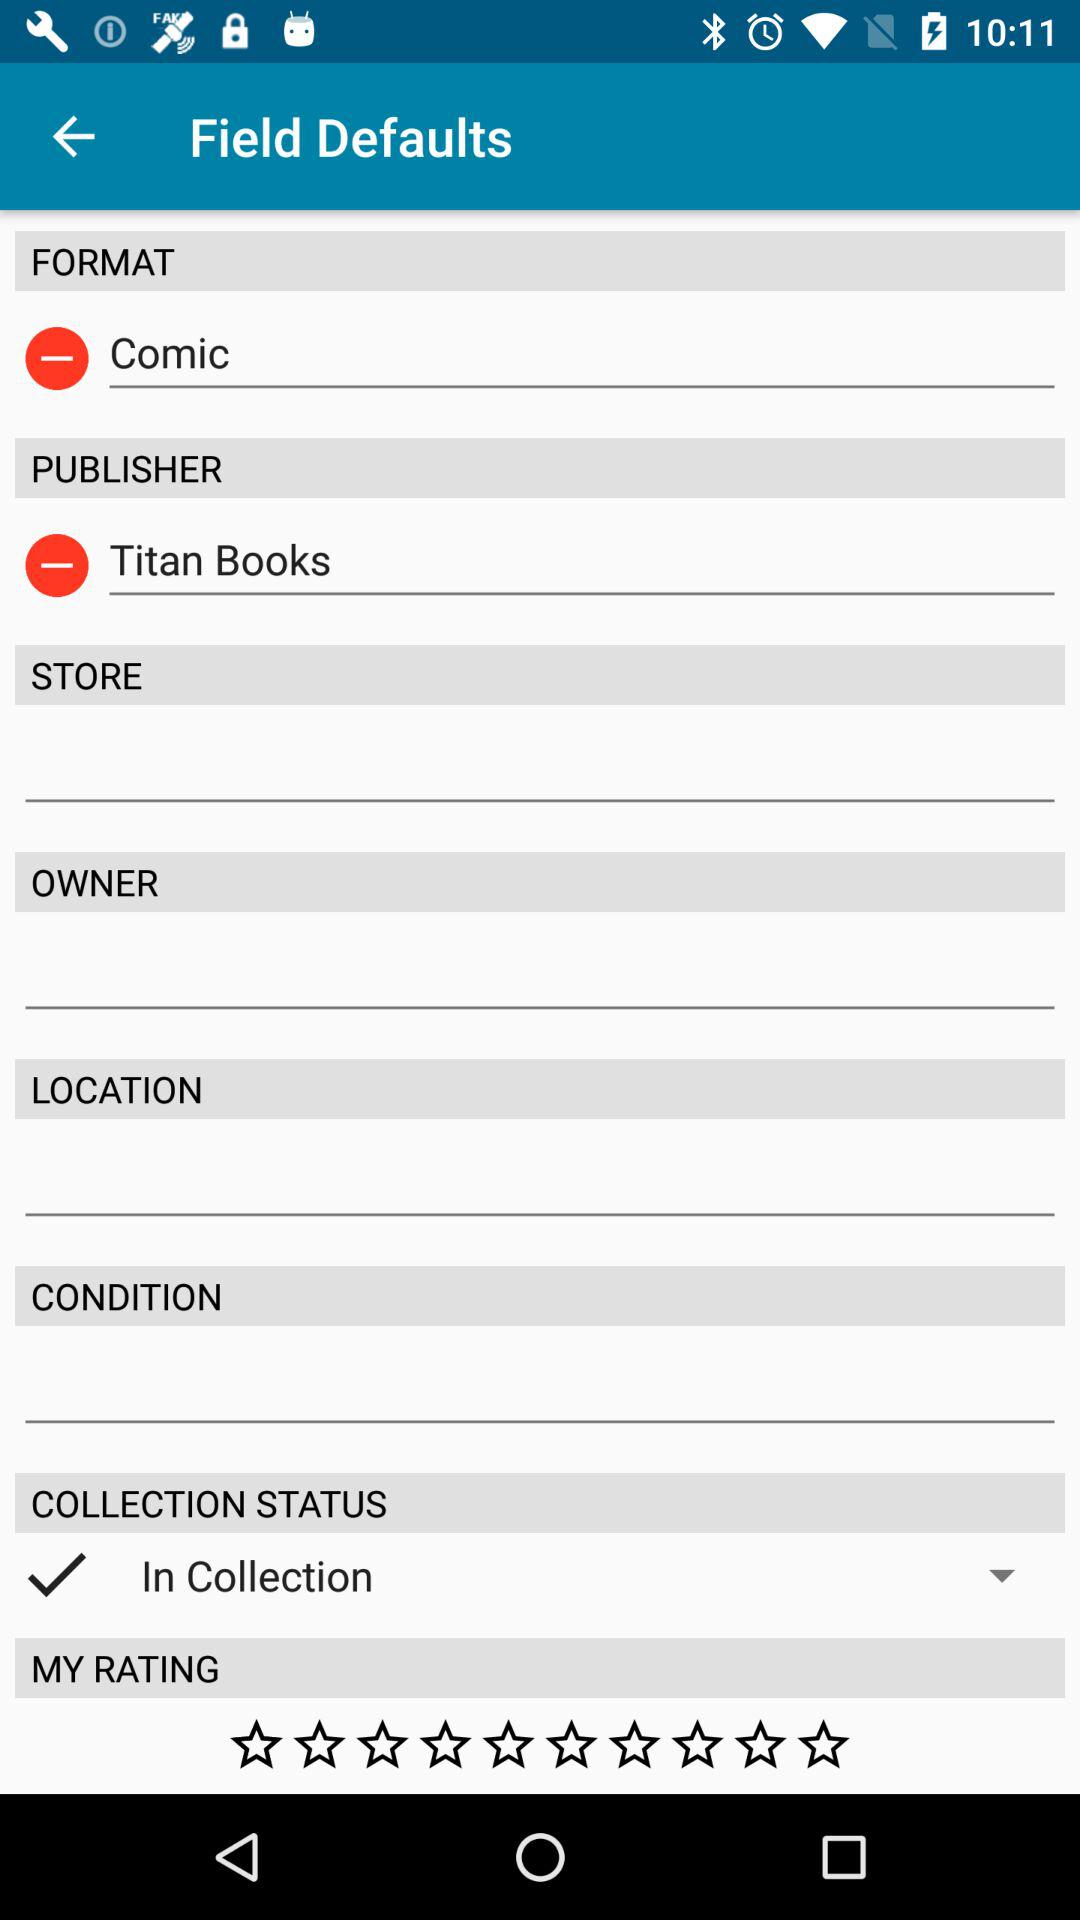How many input fields have a minus sign next to them?
Answer the question using a single word or phrase. 2 